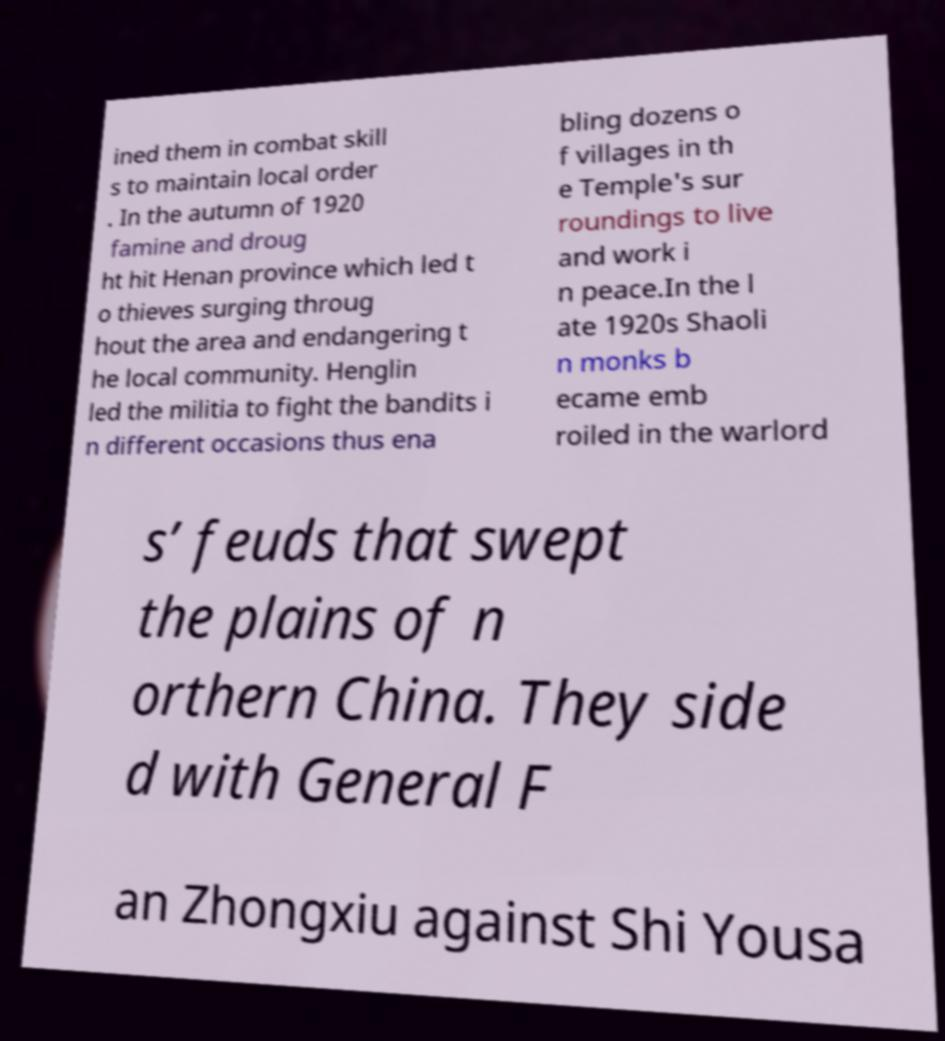Please read and relay the text visible in this image. What does it say? ined them in combat skill s to maintain local order . In the autumn of 1920 famine and droug ht hit Henan province which led t o thieves surging throug hout the area and endangering t he local community. Henglin led the militia to fight the bandits i n different occasions thus ena bling dozens o f villages in th e Temple's sur roundings to live and work i n peace.In the l ate 1920s Shaoli n monks b ecame emb roiled in the warlord s’ feuds that swept the plains of n orthern China. They side d with General F an Zhongxiu against Shi Yousa 